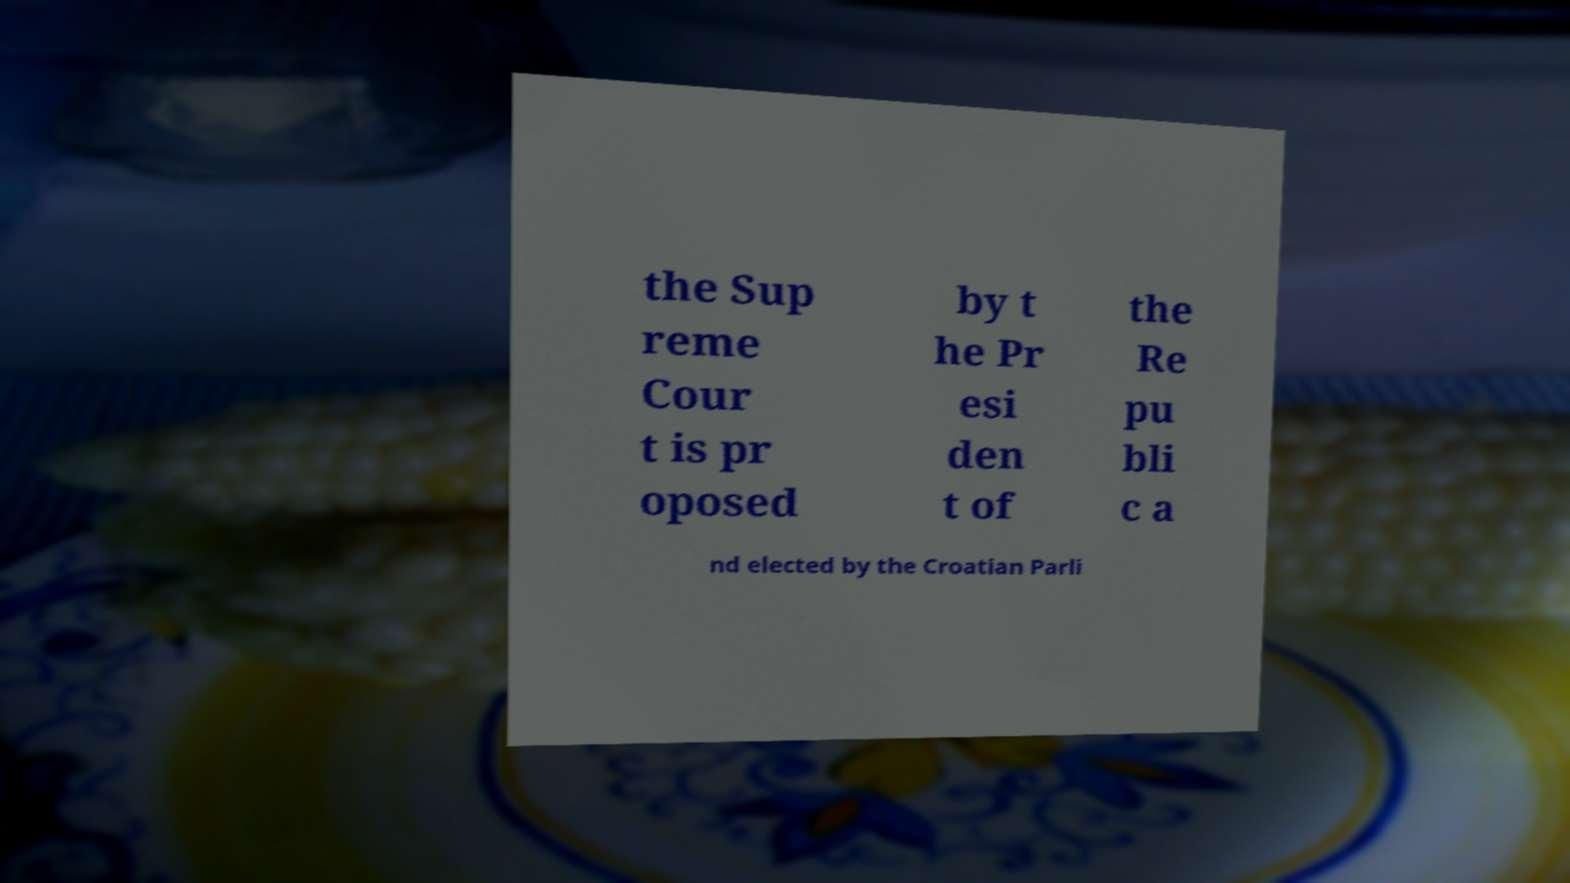Could you assist in decoding the text presented in this image and type it out clearly? the Sup reme Cour t is pr oposed by t he Pr esi den t of the Re pu bli c a nd elected by the Croatian Parli 